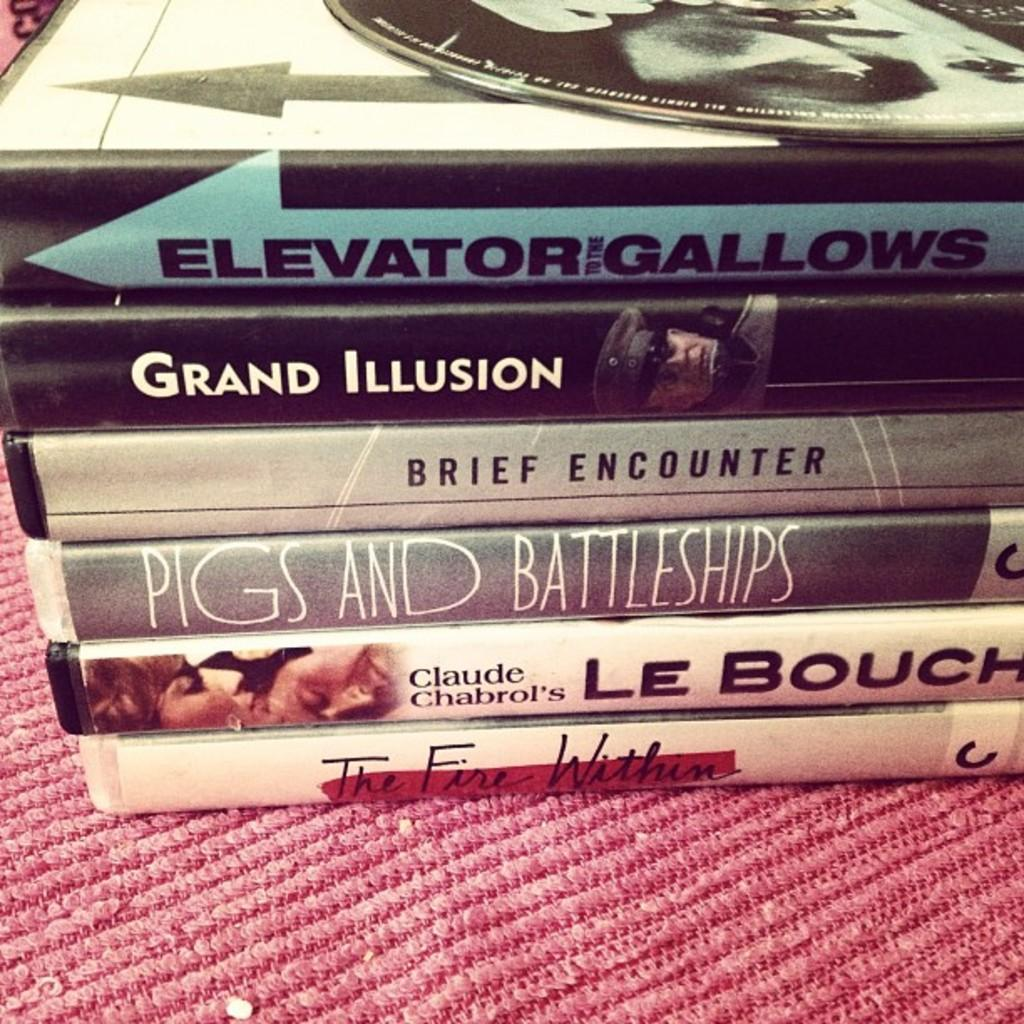<image>
Offer a succinct explanation of the picture presented. A stack of books on top of each other including one called Brief Encounter. 